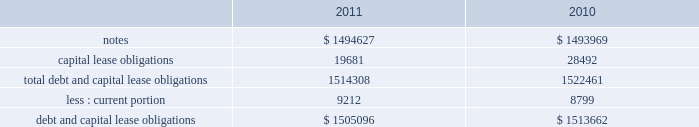Note 17 .
Debt our debt as of december 2 , 2011 and december 3 , 2010 consisted of the following ( in thousands ) : capital lease obligations total debt and capital lease obligations less : current portion debt and capital lease obligations $ 1494627 19681 1514308 $ 1505096 $ 1493969 28492 1522461 $ 1513662 in february 2010 , we issued $ 600.0 million of 3.25% ( 3.25 % ) senior notes due february 1 , 2015 ( the 201c2015 notes 201d ) and $ 900.0 million of 4.75% ( 4.75 % ) senior notes due february 1 , 2020 ( the 201c2020 notes 201d and , together with the 2015 notes , the 201cnotes 201d ) .
Our proceeds were approximately $ 1.5 billion and were net of an issuance discount of $ 6.6 million .
The notes rank equally with our other unsecured and unsubordinated indebtedness .
In addition , we incurred issuance costs of approximately $ 10.7 million .
Both the discount and issuance costs are being amortized to interest expense over the respective terms of the notes using the effective interest method .
The effective interest rate including the discount and issuance costs is 3.45% ( 3.45 % ) for the 2015 notes and 4.92% ( 4.92 % ) for the 2020 notes .
Interest is payable semi-annually , in arrears , on february 1 and august 1 , commencing on august 1 , 2010 .
During fiscal 2011 interest payments totaled $ 62.3 million .
The proceeds from the notes are available for general corporate purposes , including repayment of any balance outstanding on our credit facility .
Based on quoted market prices , the fair value of the notes was approximately $ 1.6 billion as of december 2 , 2011 .
We may redeem the notes at any time , subject to a make whole premium .
In addition , upon the occurrence of certain change of control triggering events , we may be required to repurchase the notes , at a price equal to 101% ( 101 % ) of their principal amount , plus accrued and unpaid interest to the date of repurchase .
The notes also include covenants that limit our ability to grant liens on assets and to enter into sale and leaseback transactions , subject to significant allowances .
As of december 2 , 2011 , we were in compliance with all of the covenants .
Credit agreement in august 2007 , we entered into an amendment to our credit agreement dated february 2007 ( the 201camendment 201d ) , which increased the total senior unsecured revolving facility from $ 500.0 million to $ 1.0 billion .
The amendment also permits us to request one-year extensions effective on each anniversary of the closing date of the original agreement , subject to the majority consent of the lenders .
We also retain an option to request an additional $ 500.0 million in commitments , for a maximum aggregate facility of $ 1.5 billion .
In february 2008 , we entered into a second amendment to the credit agreement dated february 26 , 2008 , which extended the maturity date of the facility by one year to february 16 , 2013 .
The facility would terminate at this date if no additional extensions have been requested and granted .
All other terms and conditions remain the same .
The facility contains a financial covenant requiring us not to exceed a certain maximum leverage ratio .
At our option , borrowings under the facility accrue interest based on either the london interbank offered rate ( 201clibor 201d ) for one , two , three or six months , or longer periods with bank consent , plus a margin according to a pricing grid tied to this financial covenant , or a base rate .
The margin is set at rates between 0.20% ( 0.20 % ) and 0.475% ( 0.475 % ) .
Commitment fees are payable on the facility at rates between 0.05% ( 0.05 % ) and 0.15% ( 0.15 % ) per year based on the same pricing grid .
The facility is available to provide loans to us and certain of our subsidiaries for general corporate purposes .
On february 1 , 2010 , we paid the outstanding balance on our credit facility and the entire $ 1.0 billion credit line under this facility remains available for borrowing .
Capital lease obligation in june 2010 , we entered into a sale-leaseback agreement to sell equipment totaling $ 32.2 million and leaseback the same equipment over a period of 43 months .
This transaction was classified as a capital lease obligation and recorded at fair value .
As of december 2 , 2011 , our capital lease obligations of $ 19.7 million includes $ 9.2 million of current debt .
Table of contents adobe systems incorporated notes to consolidated financial statements ( continued ) .
Note 17 .
Debt our debt as of december 2 , 2011 and december 3 , 2010 consisted of the following ( in thousands ) : capital lease obligations total debt and capital lease obligations less : current portion debt and capital lease obligations $ 1494627 19681 1514308 $ 1505096 $ 1493969 28492 1522461 $ 1513662 in february 2010 , we issued $ 600.0 million of 3.25% ( 3.25 % ) senior notes due february 1 , 2015 ( the 201c2015 notes 201d ) and $ 900.0 million of 4.75% ( 4.75 % ) senior notes due february 1 , 2020 ( the 201c2020 notes 201d and , together with the 2015 notes , the 201cnotes 201d ) .
Our proceeds were approximately $ 1.5 billion and were net of an issuance discount of $ 6.6 million .
The notes rank equally with our other unsecured and unsubordinated indebtedness .
In addition , we incurred issuance costs of approximately $ 10.7 million .
Both the discount and issuance costs are being amortized to interest expense over the respective terms of the notes using the effective interest method .
The effective interest rate including the discount and issuance costs is 3.45% ( 3.45 % ) for the 2015 notes and 4.92% ( 4.92 % ) for the 2020 notes .
Interest is payable semi-annually , in arrears , on february 1 and august 1 , commencing on august 1 , 2010 .
During fiscal 2011 interest payments totaled $ 62.3 million .
The proceeds from the notes are available for general corporate purposes , including repayment of any balance outstanding on our credit facility .
Based on quoted market prices , the fair value of the notes was approximately $ 1.6 billion as of december 2 , 2011 .
We may redeem the notes at any time , subject to a make whole premium .
In addition , upon the occurrence of certain change of control triggering events , we may be required to repurchase the notes , at a price equal to 101% ( 101 % ) of their principal amount , plus accrued and unpaid interest to the date of repurchase .
The notes also include covenants that limit our ability to grant liens on assets and to enter into sale and leaseback transactions , subject to significant allowances .
As of december 2 , 2011 , we were in compliance with all of the covenants .
Credit agreement in august 2007 , we entered into an amendment to our credit agreement dated february 2007 ( the 201camendment 201d ) , which increased the total senior unsecured revolving facility from $ 500.0 million to $ 1.0 billion .
The amendment also permits us to request one-year extensions effective on each anniversary of the closing date of the original agreement , subject to the majority consent of the lenders .
We also retain an option to request an additional $ 500.0 million in commitments , for a maximum aggregate facility of $ 1.5 billion .
In february 2008 , we entered into a second amendment to the credit agreement dated february 26 , 2008 , which extended the maturity date of the facility by one year to february 16 , 2013 .
The facility would terminate at this date if no additional extensions have been requested and granted .
All other terms and conditions remain the same .
The facility contains a financial covenant requiring us not to exceed a certain maximum leverage ratio .
At our option , borrowings under the facility accrue interest based on either the london interbank offered rate ( 201clibor 201d ) for one , two , three or six months , or longer periods with bank consent , plus a margin according to a pricing grid tied to this financial covenant , or a base rate .
The margin is set at rates between 0.20% ( 0.20 % ) and 0.475% ( 0.475 % ) .
Commitment fees are payable on the facility at rates between 0.05% ( 0.05 % ) and 0.15% ( 0.15 % ) per year based on the same pricing grid .
The facility is available to provide loans to us and certain of our subsidiaries for general corporate purposes .
On february 1 , 2010 , we paid the outstanding balance on our credit facility and the entire $ 1.0 billion credit line under this facility remains available for borrowing .
Capital lease obligation in june 2010 , we entered into a sale-leaseback agreement to sell equipment totaling $ 32.2 million and leaseback the same equipment over a period of 43 months .
This transaction was classified as a capital lease obligation and recorded at fair value .
As of december 2 , 2011 , our capital lease obligations of $ 19.7 million includes $ 9.2 million of current debt .
Table of contents adobe systems incorporated notes to consolidated financial statements ( continued ) .
What is total capital lease obligations in millions? 
Computations: table_sum(capital lease obligations, none)
Answer: 48173.0. 